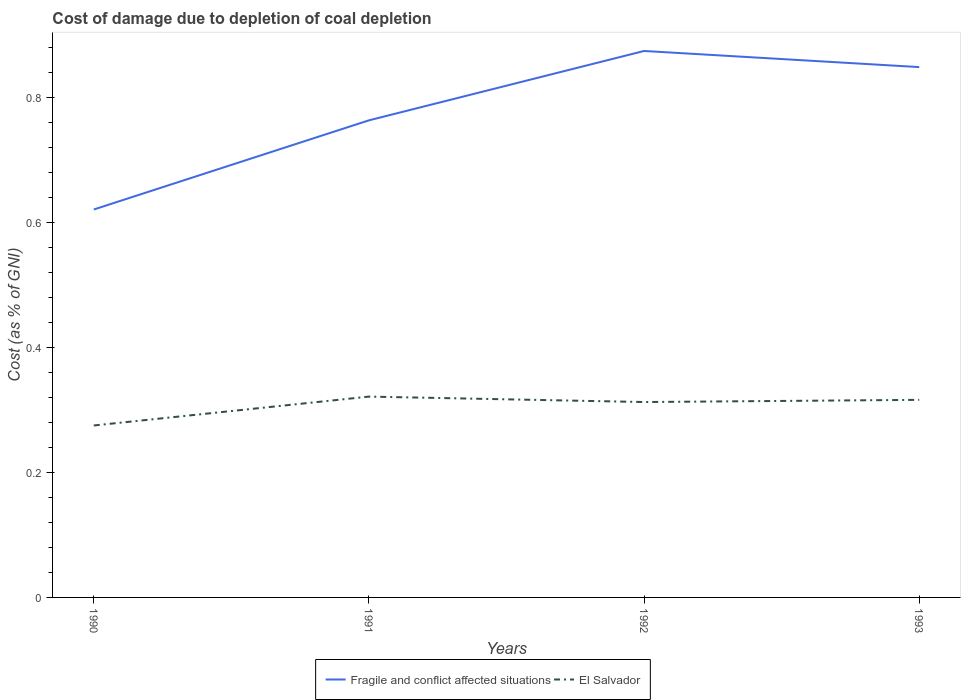How many different coloured lines are there?
Offer a terse response. 2. Across all years, what is the maximum cost of damage caused due to coal depletion in Fragile and conflict affected situations?
Keep it short and to the point. 0.62. What is the total cost of damage caused due to coal depletion in El Salvador in the graph?
Your response must be concise. -0.04. What is the difference between the highest and the second highest cost of damage caused due to coal depletion in Fragile and conflict affected situations?
Keep it short and to the point. 0.25. What is the difference between the highest and the lowest cost of damage caused due to coal depletion in El Salvador?
Your answer should be compact. 3. Is the cost of damage caused due to coal depletion in El Salvador strictly greater than the cost of damage caused due to coal depletion in Fragile and conflict affected situations over the years?
Your answer should be compact. Yes. How many lines are there?
Your answer should be very brief. 2. How many years are there in the graph?
Offer a terse response. 4. What is the difference between two consecutive major ticks on the Y-axis?
Provide a succinct answer. 0.2. Does the graph contain any zero values?
Give a very brief answer. No. Does the graph contain grids?
Your answer should be compact. No. What is the title of the graph?
Ensure brevity in your answer.  Cost of damage due to depletion of coal depletion. Does "South Asia" appear as one of the legend labels in the graph?
Give a very brief answer. No. What is the label or title of the Y-axis?
Offer a very short reply. Cost (as % of GNI). What is the Cost (as % of GNI) in Fragile and conflict affected situations in 1990?
Offer a terse response. 0.62. What is the Cost (as % of GNI) of El Salvador in 1990?
Keep it short and to the point. 0.28. What is the Cost (as % of GNI) of Fragile and conflict affected situations in 1991?
Ensure brevity in your answer.  0.76. What is the Cost (as % of GNI) in El Salvador in 1991?
Offer a very short reply. 0.32. What is the Cost (as % of GNI) in Fragile and conflict affected situations in 1992?
Give a very brief answer. 0.88. What is the Cost (as % of GNI) of El Salvador in 1992?
Your answer should be very brief. 0.31. What is the Cost (as % of GNI) of Fragile and conflict affected situations in 1993?
Ensure brevity in your answer.  0.85. What is the Cost (as % of GNI) in El Salvador in 1993?
Make the answer very short. 0.32. Across all years, what is the maximum Cost (as % of GNI) in Fragile and conflict affected situations?
Offer a very short reply. 0.88. Across all years, what is the maximum Cost (as % of GNI) in El Salvador?
Ensure brevity in your answer.  0.32. Across all years, what is the minimum Cost (as % of GNI) in Fragile and conflict affected situations?
Your response must be concise. 0.62. Across all years, what is the minimum Cost (as % of GNI) of El Salvador?
Your answer should be compact. 0.28. What is the total Cost (as % of GNI) in Fragile and conflict affected situations in the graph?
Your answer should be very brief. 3.11. What is the total Cost (as % of GNI) in El Salvador in the graph?
Your answer should be compact. 1.23. What is the difference between the Cost (as % of GNI) in Fragile and conflict affected situations in 1990 and that in 1991?
Give a very brief answer. -0.14. What is the difference between the Cost (as % of GNI) in El Salvador in 1990 and that in 1991?
Keep it short and to the point. -0.05. What is the difference between the Cost (as % of GNI) in Fragile and conflict affected situations in 1990 and that in 1992?
Ensure brevity in your answer.  -0.25. What is the difference between the Cost (as % of GNI) of El Salvador in 1990 and that in 1992?
Make the answer very short. -0.04. What is the difference between the Cost (as % of GNI) in Fragile and conflict affected situations in 1990 and that in 1993?
Your answer should be compact. -0.23. What is the difference between the Cost (as % of GNI) in El Salvador in 1990 and that in 1993?
Offer a terse response. -0.04. What is the difference between the Cost (as % of GNI) in Fragile and conflict affected situations in 1991 and that in 1992?
Offer a very short reply. -0.11. What is the difference between the Cost (as % of GNI) of El Salvador in 1991 and that in 1992?
Offer a very short reply. 0.01. What is the difference between the Cost (as % of GNI) in Fragile and conflict affected situations in 1991 and that in 1993?
Your response must be concise. -0.09. What is the difference between the Cost (as % of GNI) in El Salvador in 1991 and that in 1993?
Ensure brevity in your answer.  0.01. What is the difference between the Cost (as % of GNI) of Fragile and conflict affected situations in 1992 and that in 1993?
Give a very brief answer. 0.03. What is the difference between the Cost (as % of GNI) of El Salvador in 1992 and that in 1993?
Your response must be concise. -0. What is the difference between the Cost (as % of GNI) in Fragile and conflict affected situations in 1990 and the Cost (as % of GNI) in El Salvador in 1991?
Your answer should be compact. 0.3. What is the difference between the Cost (as % of GNI) in Fragile and conflict affected situations in 1990 and the Cost (as % of GNI) in El Salvador in 1992?
Offer a terse response. 0.31. What is the difference between the Cost (as % of GNI) of Fragile and conflict affected situations in 1990 and the Cost (as % of GNI) of El Salvador in 1993?
Make the answer very short. 0.3. What is the difference between the Cost (as % of GNI) in Fragile and conflict affected situations in 1991 and the Cost (as % of GNI) in El Salvador in 1992?
Keep it short and to the point. 0.45. What is the difference between the Cost (as % of GNI) of Fragile and conflict affected situations in 1991 and the Cost (as % of GNI) of El Salvador in 1993?
Offer a very short reply. 0.45. What is the difference between the Cost (as % of GNI) in Fragile and conflict affected situations in 1992 and the Cost (as % of GNI) in El Salvador in 1993?
Your answer should be very brief. 0.56. What is the average Cost (as % of GNI) in Fragile and conflict affected situations per year?
Offer a very short reply. 0.78. What is the average Cost (as % of GNI) in El Salvador per year?
Offer a very short reply. 0.31. In the year 1990, what is the difference between the Cost (as % of GNI) of Fragile and conflict affected situations and Cost (as % of GNI) of El Salvador?
Your response must be concise. 0.35. In the year 1991, what is the difference between the Cost (as % of GNI) of Fragile and conflict affected situations and Cost (as % of GNI) of El Salvador?
Your answer should be compact. 0.44. In the year 1992, what is the difference between the Cost (as % of GNI) in Fragile and conflict affected situations and Cost (as % of GNI) in El Salvador?
Make the answer very short. 0.56. In the year 1993, what is the difference between the Cost (as % of GNI) in Fragile and conflict affected situations and Cost (as % of GNI) in El Salvador?
Ensure brevity in your answer.  0.53. What is the ratio of the Cost (as % of GNI) in Fragile and conflict affected situations in 1990 to that in 1991?
Provide a short and direct response. 0.81. What is the ratio of the Cost (as % of GNI) in El Salvador in 1990 to that in 1991?
Ensure brevity in your answer.  0.86. What is the ratio of the Cost (as % of GNI) of Fragile and conflict affected situations in 1990 to that in 1992?
Offer a very short reply. 0.71. What is the ratio of the Cost (as % of GNI) in El Salvador in 1990 to that in 1992?
Offer a terse response. 0.88. What is the ratio of the Cost (as % of GNI) of Fragile and conflict affected situations in 1990 to that in 1993?
Ensure brevity in your answer.  0.73. What is the ratio of the Cost (as % of GNI) in El Salvador in 1990 to that in 1993?
Provide a short and direct response. 0.87. What is the ratio of the Cost (as % of GNI) in Fragile and conflict affected situations in 1991 to that in 1992?
Your answer should be very brief. 0.87. What is the ratio of the Cost (as % of GNI) in El Salvador in 1991 to that in 1992?
Keep it short and to the point. 1.03. What is the ratio of the Cost (as % of GNI) of Fragile and conflict affected situations in 1991 to that in 1993?
Your answer should be compact. 0.9. What is the ratio of the Cost (as % of GNI) in El Salvador in 1991 to that in 1993?
Ensure brevity in your answer.  1.02. What is the ratio of the Cost (as % of GNI) of Fragile and conflict affected situations in 1992 to that in 1993?
Provide a succinct answer. 1.03. What is the ratio of the Cost (as % of GNI) of El Salvador in 1992 to that in 1993?
Ensure brevity in your answer.  0.99. What is the difference between the highest and the second highest Cost (as % of GNI) in Fragile and conflict affected situations?
Provide a short and direct response. 0.03. What is the difference between the highest and the second highest Cost (as % of GNI) of El Salvador?
Offer a very short reply. 0.01. What is the difference between the highest and the lowest Cost (as % of GNI) of Fragile and conflict affected situations?
Make the answer very short. 0.25. What is the difference between the highest and the lowest Cost (as % of GNI) of El Salvador?
Your answer should be very brief. 0.05. 